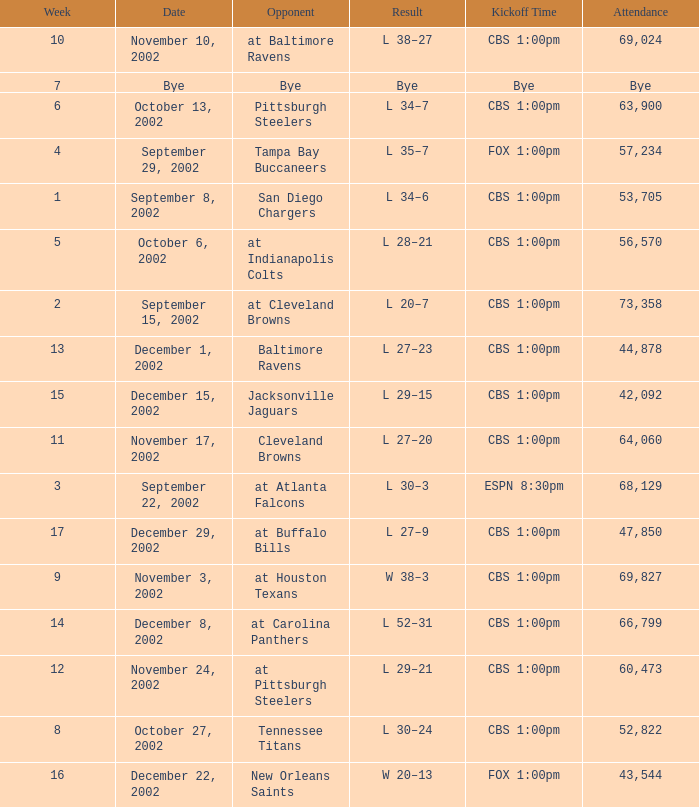What is the kickoff time for the game in week of 17? CBS 1:00pm. 